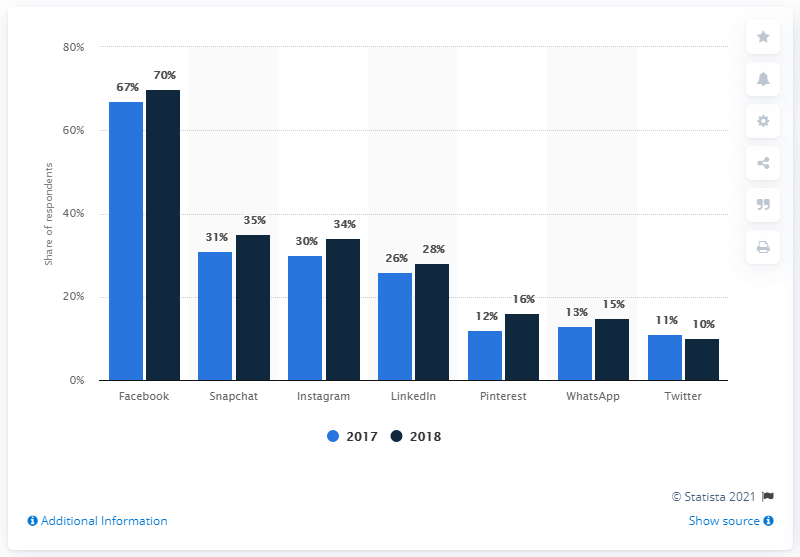Highlight a few significant elements in this photo. The dark blue bar is taller than the light blue bar in Whatsapp. According to the data, Twitter was the social media site that had the smallest difference in respondents' share between 2017 and 2018. In 2017 and 2018, Facebook was the social media site with the highest share of users in Denmark. 